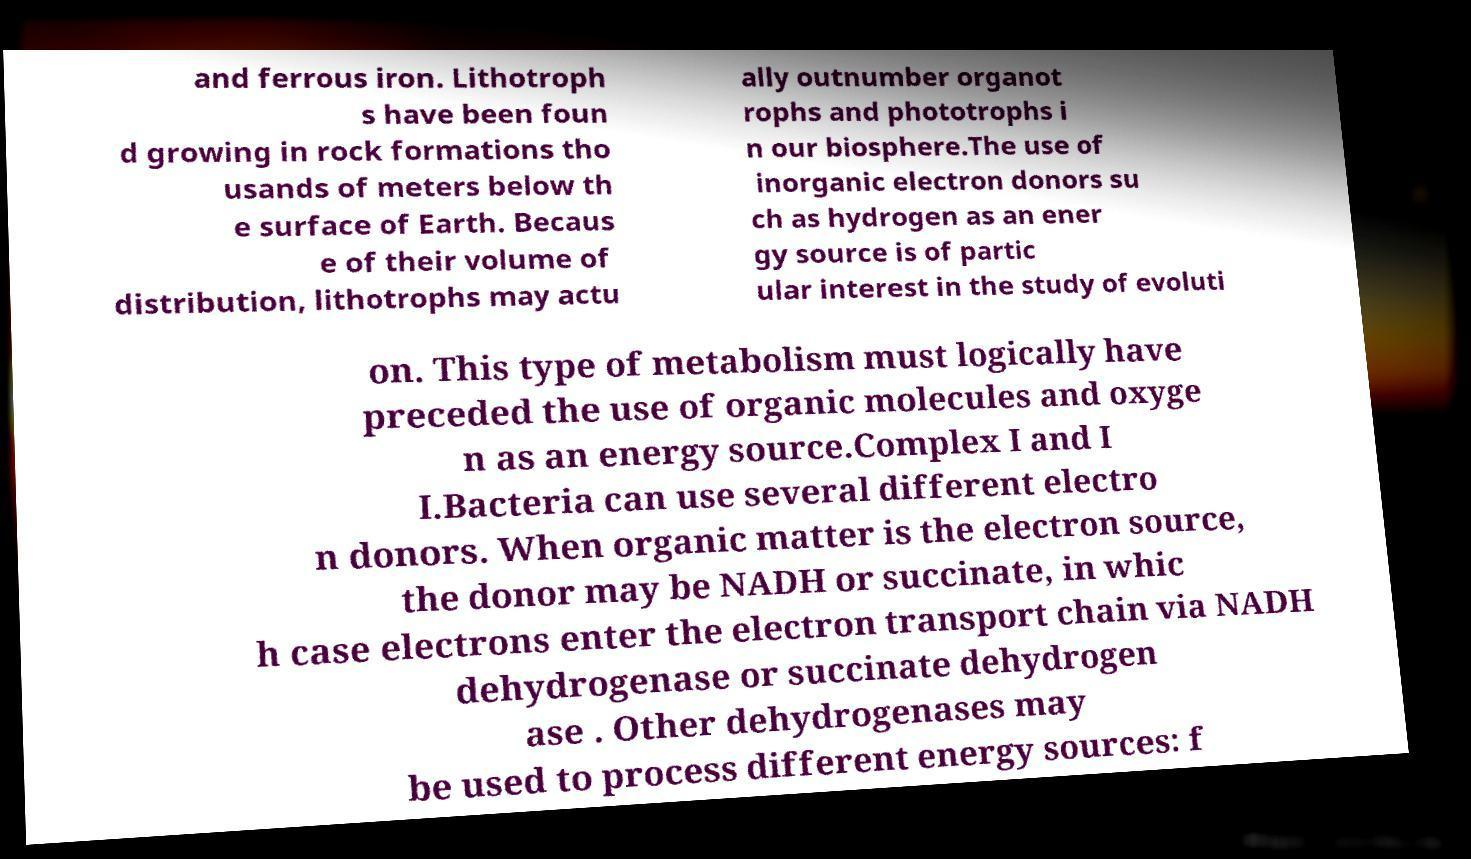Could you assist in decoding the text presented in this image and type it out clearly? and ferrous iron. Lithotroph s have been foun d growing in rock formations tho usands of meters below th e surface of Earth. Becaus e of their volume of distribution, lithotrophs may actu ally outnumber organot rophs and phototrophs i n our biosphere.The use of inorganic electron donors su ch as hydrogen as an ener gy source is of partic ular interest in the study of evoluti on. This type of metabolism must logically have preceded the use of organic molecules and oxyge n as an energy source.Complex I and I I.Bacteria can use several different electro n donors. When organic matter is the electron source, the donor may be NADH or succinate, in whic h case electrons enter the electron transport chain via NADH dehydrogenase or succinate dehydrogen ase . Other dehydrogenases may be used to process different energy sources: f 